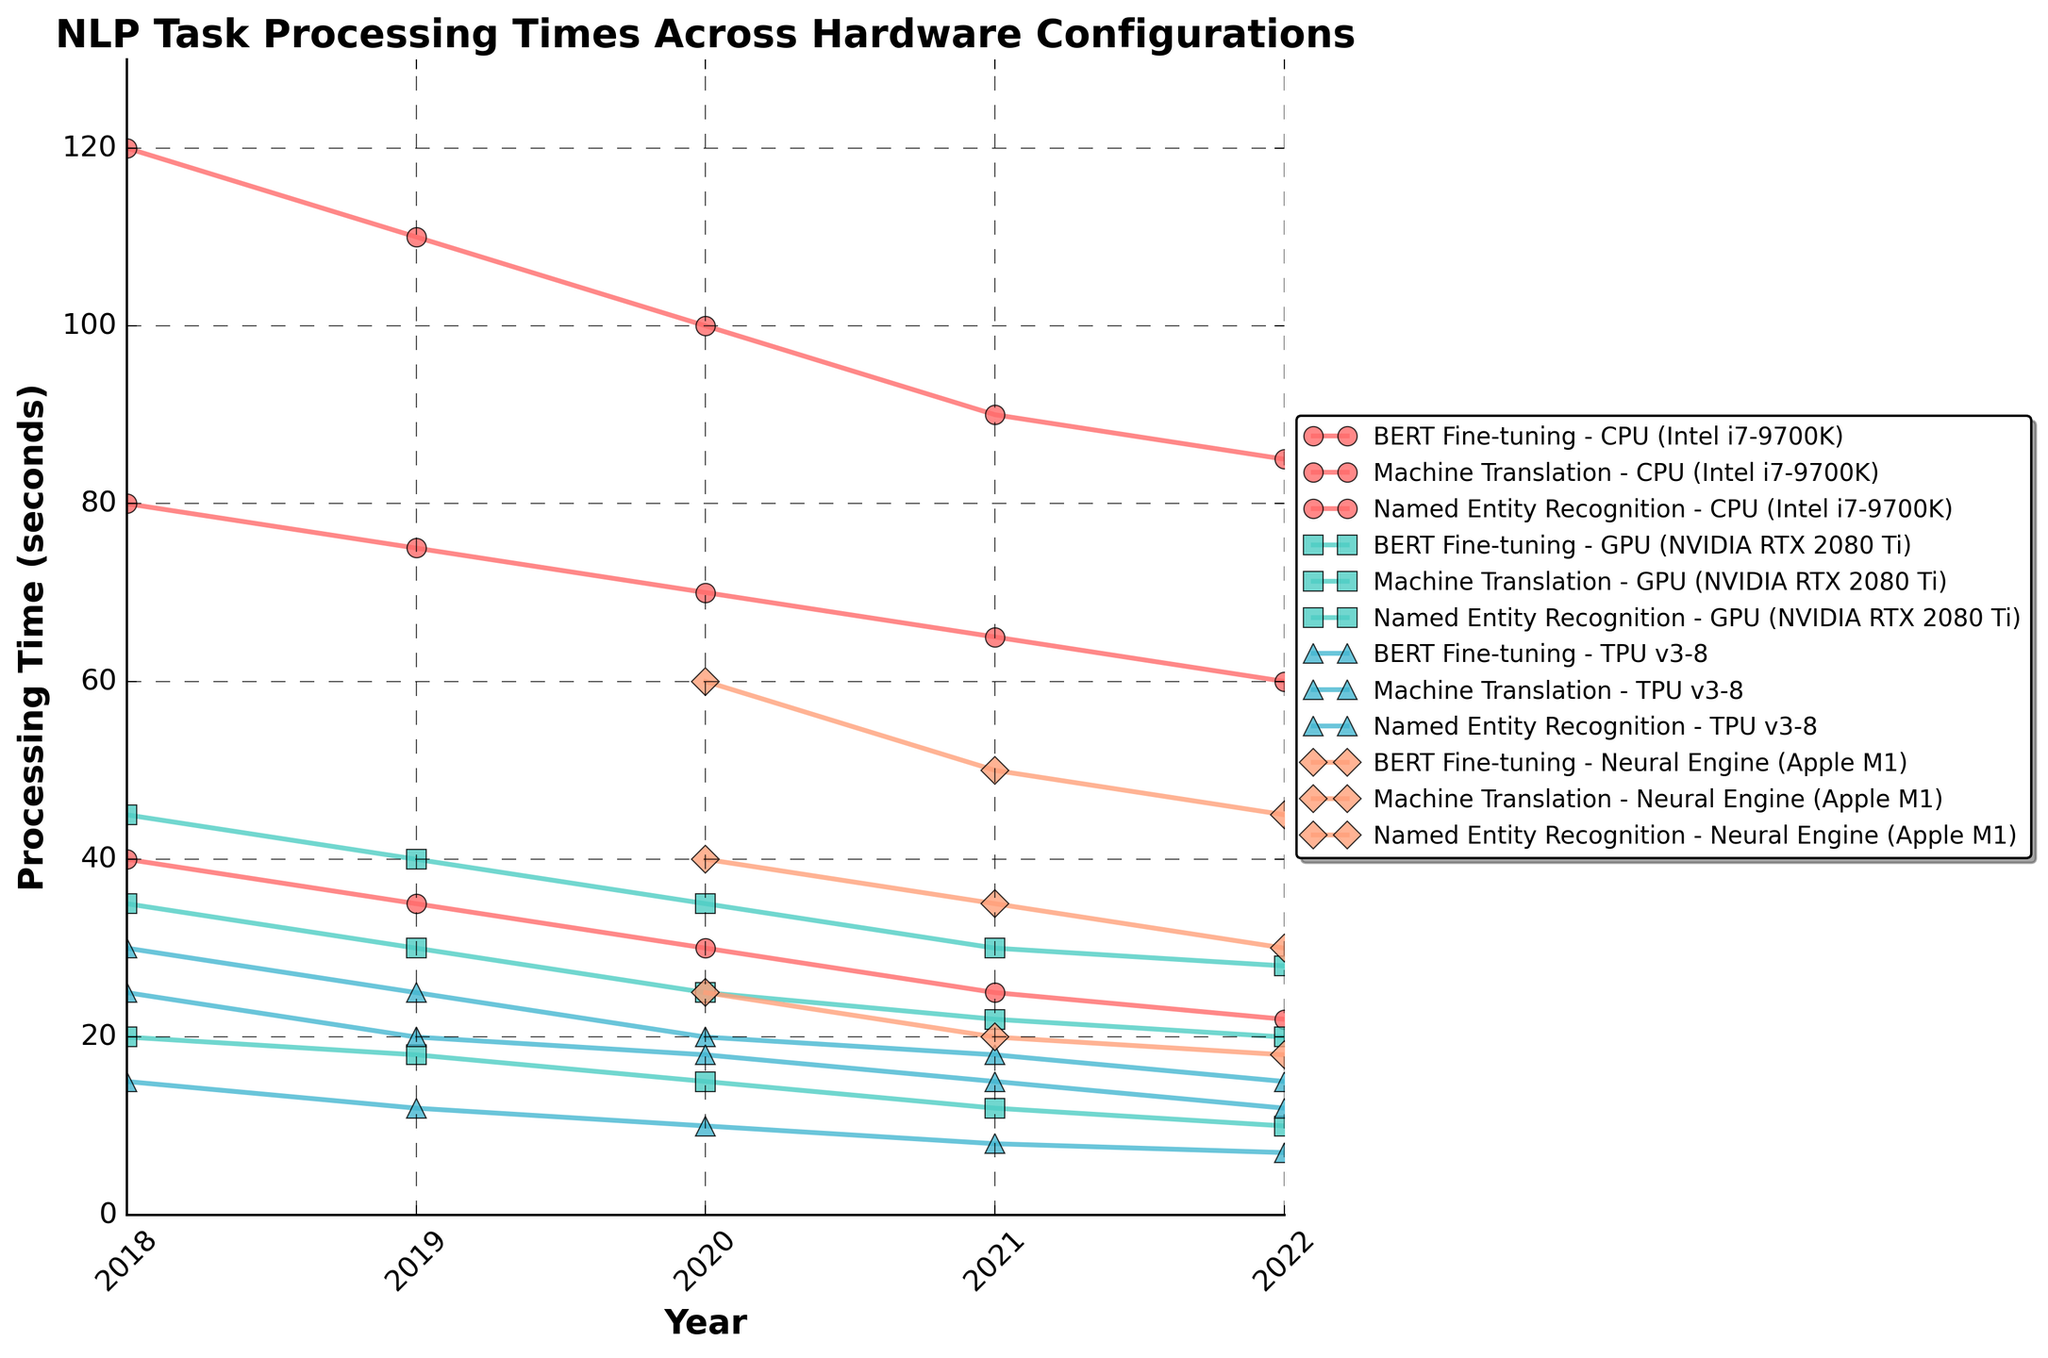What year saw the introduction of the Apple M1 Neural Engine in processing NLP tasks? All tasks (BERT Fine-tuning, Machine Translation, Named Entity Recognition) show data for the Neural Engine starting from 2020, indicating its introduction in that year.
Answer: 2020 Which hardware configuration showed the greatest reduction in processing time for BERT Fine-tuning from 2018 to 2022? Comparing BERT Fine-tuning data, the CPU (Intel i7-9700K) decreased from 120 to 85 seconds, GPU (NVIDIA RTX 2080 Ti) from 45 to 28 seconds, TPU v3-8 from 30 to 15 seconds. The TPU v3-8 shows the greatest reduction of 15 seconds.
Answer: TPU v3-8 How does the processing time for Machine Translation on GPU in 2021 compare to CPU in the same year? In 2021, the processing time for Machine Translation was 22 seconds on the GPU and 65 seconds on the CPU. Comparing these values, the GPU performed the task faster.
Answer: The GPU was faster What was the processing time difference for Named Entity Recognition between TPU v3-8 and Neural Engine in 2022? In 2022, the processing times for Named Entity Recognition were 7 seconds on TPU v3-8 and 18 seconds on the Neural Engine. The difference is calculated as 18 - 7 = 11 seconds.
Answer: 11 seconds Which task consistently had the lowest processing times across all years for TPU v3-8? Observing the processing times across each year for TPU v3-8, Named Entity Recognition consistently recorded the lowest times: 15s (2018), 12s (2019), 10s (2020), 8s (2021), 7s (2022).
Answer: Named Entity Recognition By how much did the processing time for Machine Translation on the Intel CPU decrease from 2018 to 2022? The processing time for Machine Translation on the Intel CPU was 80 seconds in 2018 and 60 seconds in 2022. The decrease is 80 - 60 = 20 seconds.
Answer: 20 seconds Which hardware configuration showed the least improvement for processing Named Entity Recognition from 2018 to 2022? For Named Entity Recognition, comparing data, CPU decreased from 40 to 22 seconds, GPU from 20 to 10 seconds, TPU v3-8 from 15 to 7 seconds. Since the Neural Engine data starts in 2020, we focus on these three, where CPU had the smallest reduction (18 seconds).
Answer: CPU (Intel i7-9700K) 